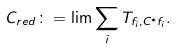<formula> <loc_0><loc_0><loc_500><loc_500>C _ { r e d } \colon = \lim \sum _ { i } T _ { f _ { i } , C ^ { * } f _ { i } } .</formula> 